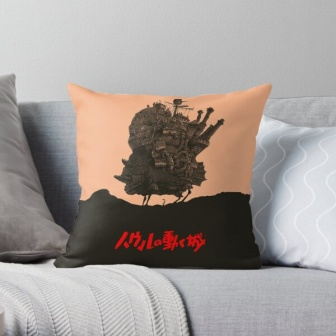If this image were part of a movie scene, what might be happening in the story? If this image were part of a movie scene, it might be a quiet moment in a larger story. The main character, perhaps an artist or storyteller, sits on the gray couch, leaning against the pillow while sketching new ideas or reading a fantastical novel for inspiration. The room, filled with cozy and imaginative decor, serves as a retreat where the character finds comfort and spurs their creativity. This scene could be a prelude to the character embarking on a magical journey, with the pillow’s castle tying into the fantasy world they are about to explore. The details in the decor hint at the character’s deep love for fantasy and storytelling, setting the tone for the adventures to come. 